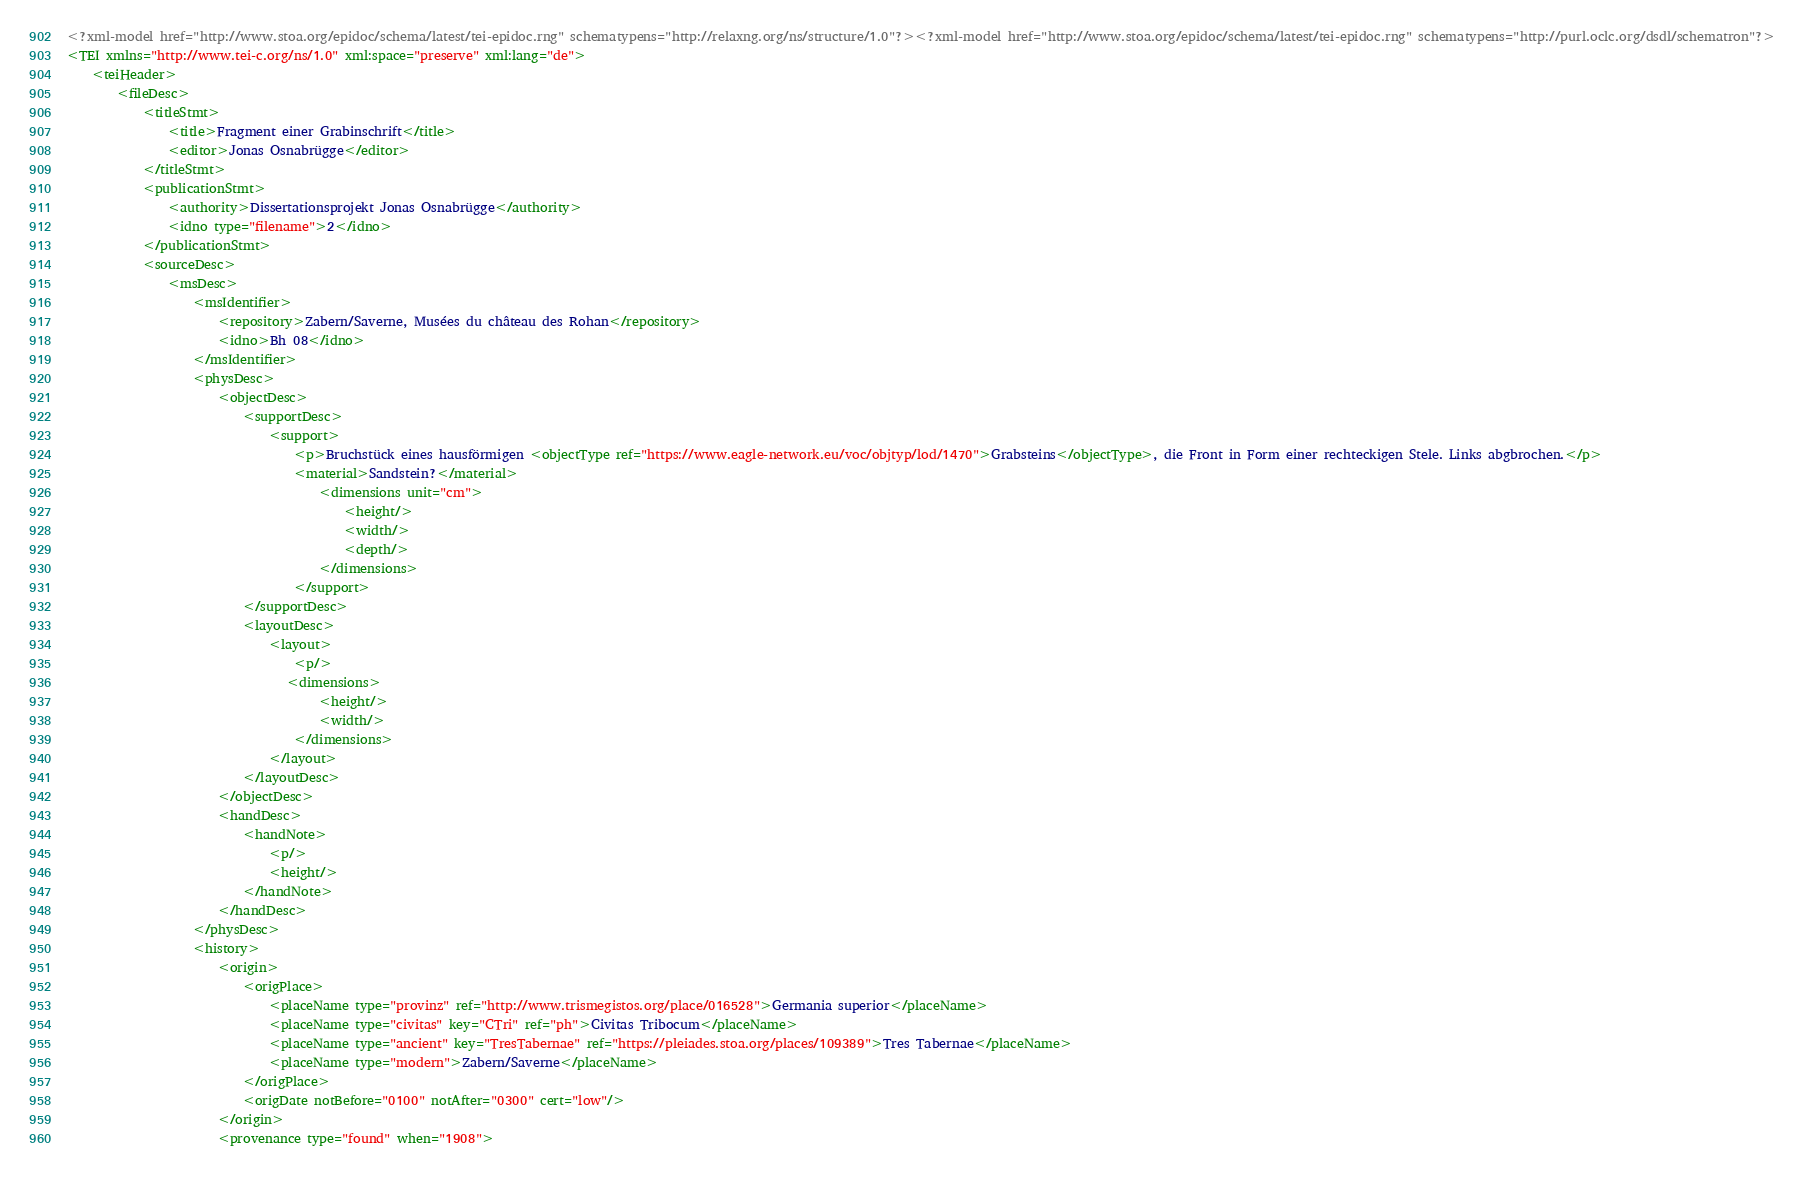<code> <loc_0><loc_0><loc_500><loc_500><_XML_><?xml-model href="http://www.stoa.org/epidoc/schema/latest/tei-epidoc.rng" schematypens="http://relaxng.org/ns/structure/1.0"?><?xml-model href="http://www.stoa.org/epidoc/schema/latest/tei-epidoc.rng" schematypens="http://purl.oclc.org/dsdl/schematron"?>
<TEI xmlns="http://www.tei-c.org/ns/1.0" xml:space="preserve" xml:lang="de">
    <teiHeader>
        <fileDesc>
            <titleStmt>
                <title>Fragment einer Grabinschrift</title>
                <editor>Jonas Osnabrügge</editor>
            </titleStmt>
            <publicationStmt>
                <authority>Dissertationsprojekt Jonas Osnabrügge</authority>
                <idno type="filename">2</idno>
            </publicationStmt>
            <sourceDesc>
                <msDesc>
                    <msIdentifier>
                        <repository>Zabern/Saverne, Musées du château des Rohan</repository>
                        <idno>Bh 08</idno>
                    </msIdentifier>
                    <physDesc>
                        <objectDesc>
                            <supportDesc>
                                <support>
                                    <p>Bruchstück eines hausförmigen <objectType ref="https://www.eagle-network.eu/voc/objtyp/lod/1470">Grabsteins</objectType>, die Front in Form einer rechteckigen Stele. Links abgbrochen.</p>
                                    <material>Sandstein?</material>
                                        <dimensions unit="cm">
                                            <height/>
                                            <width/>
                                            <depth/>
                                        </dimensions>
                                    </support>
                            </supportDesc>
                            <layoutDesc>
                                <layout>
                                    <p/>
                                   <dimensions>
                                        <height/>
                                        <width/>
                                    </dimensions>
                                </layout>
                            </layoutDesc>
                        </objectDesc>
                        <handDesc>
                            <handNote>
                                <p/>
                                <height/>
                            </handNote>
                        </handDesc>
                    </physDesc>
                    <history>
                        <origin>
                            <origPlace>
                                <placeName type="provinz" ref="http://www.trismegistos.org/place/016528">Germania superior</placeName>
                                <placeName type="civitas" key="CTri" ref="ph">Civitas Tribocum</placeName>
                                <placeName type="ancient" key="TresTabernae" ref="https://pleiades.stoa.org/places/109389">Tres Tabernae</placeName>
                                <placeName type="modern">Zabern/Saverne</placeName> 
                            </origPlace>
                            <origDate notBefore="0100" notAfter="0300" cert="low"/>
                        </origin>
                        <provenance type="found" when="1908"></code> 